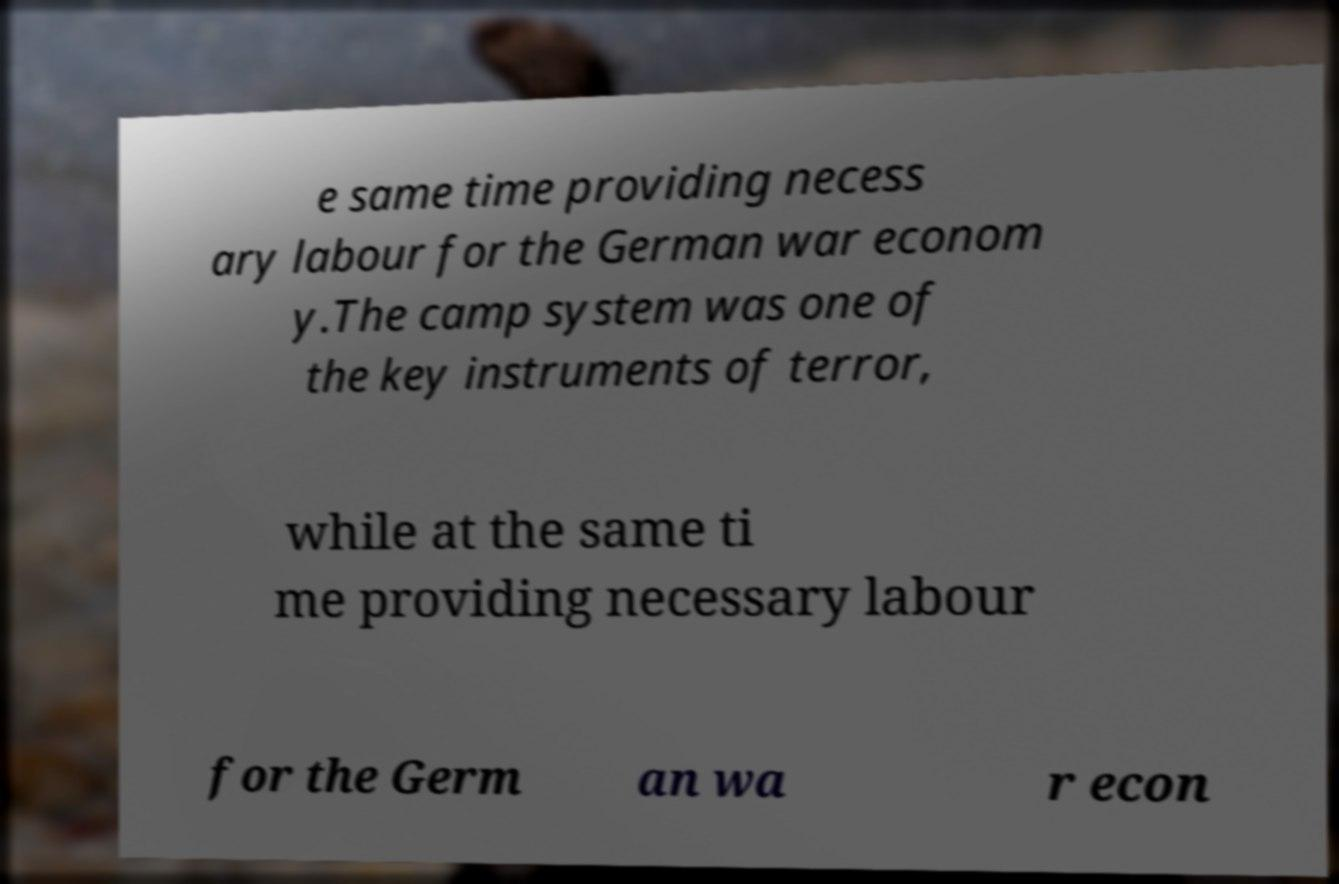What messages or text are displayed in this image? I need them in a readable, typed format. e same time providing necess ary labour for the German war econom y.The camp system was one of the key instruments of terror, while at the same ti me providing necessary labour for the Germ an wa r econ 